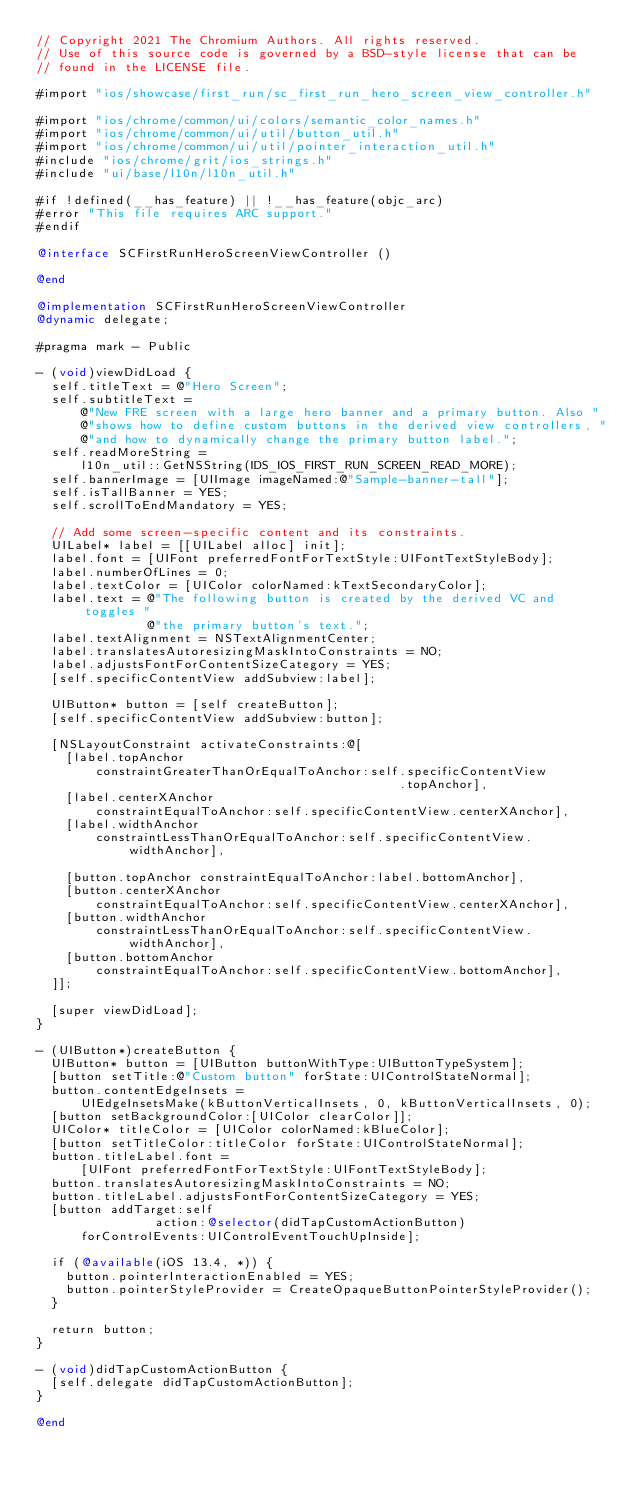Convert code to text. <code><loc_0><loc_0><loc_500><loc_500><_ObjectiveC_>// Copyright 2021 The Chromium Authors. All rights reserved.
// Use of this source code is governed by a BSD-style license that can be
// found in the LICENSE file.

#import "ios/showcase/first_run/sc_first_run_hero_screen_view_controller.h"

#import "ios/chrome/common/ui/colors/semantic_color_names.h"
#import "ios/chrome/common/ui/util/button_util.h"
#import "ios/chrome/common/ui/util/pointer_interaction_util.h"
#include "ios/chrome/grit/ios_strings.h"
#include "ui/base/l10n/l10n_util.h"

#if !defined(__has_feature) || !__has_feature(objc_arc)
#error "This file requires ARC support."
#endif

@interface SCFirstRunHeroScreenViewController ()

@end

@implementation SCFirstRunHeroScreenViewController
@dynamic delegate;

#pragma mark - Public

- (void)viewDidLoad {
  self.titleText = @"Hero Screen";
  self.subtitleText =
      @"New FRE screen with a large hero banner and a primary button. Also "
      @"shows how to define custom buttons in the derived view controllers, "
      @"and how to dynamically change the primary button label.";
  self.readMoreString =
      l10n_util::GetNSString(IDS_IOS_FIRST_RUN_SCREEN_READ_MORE);
  self.bannerImage = [UIImage imageNamed:@"Sample-banner-tall"];
  self.isTallBanner = YES;
  self.scrollToEndMandatory = YES;

  // Add some screen-specific content and its constraints.
  UILabel* label = [[UILabel alloc] init];
  label.font = [UIFont preferredFontForTextStyle:UIFontTextStyleBody];
  label.numberOfLines = 0;
  label.textColor = [UIColor colorNamed:kTextSecondaryColor];
  label.text = @"The following button is created by the derived VC and toggles "
               @"the primary button's text.";
  label.textAlignment = NSTextAlignmentCenter;
  label.translatesAutoresizingMaskIntoConstraints = NO;
  label.adjustsFontForContentSizeCategory = YES;
  [self.specificContentView addSubview:label];

  UIButton* button = [self createButton];
  [self.specificContentView addSubview:button];

  [NSLayoutConstraint activateConstraints:@[
    [label.topAnchor
        constraintGreaterThanOrEqualToAnchor:self.specificContentView
                                                 .topAnchor],
    [label.centerXAnchor
        constraintEqualToAnchor:self.specificContentView.centerXAnchor],
    [label.widthAnchor
        constraintLessThanOrEqualToAnchor:self.specificContentView.widthAnchor],

    [button.topAnchor constraintEqualToAnchor:label.bottomAnchor],
    [button.centerXAnchor
        constraintEqualToAnchor:self.specificContentView.centerXAnchor],
    [button.widthAnchor
        constraintLessThanOrEqualToAnchor:self.specificContentView.widthAnchor],
    [button.bottomAnchor
        constraintEqualToAnchor:self.specificContentView.bottomAnchor],
  ]];

  [super viewDidLoad];
}

- (UIButton*)createButton {
  UIButton* button = [UIButton buttonWithType:UIButtonTypeSystem];
  [button setTitle:@"Custom button" forState:UIControlStateNormal];
  button.contentEdgeInsets =
      UIEdgeInsetsMake(kButtonVerticalInsets, 0, kButtonVerticalInsets, 0);
  [button setBackgroundColor:[UIColor clearColor]];
  UIColor* titleColor = [UIColor colorNamed:kBlueColor];
  [button setTitleColor:titleColor forState:UIControlStateNormal];
  button.titleLabel.font =
      [UIFont preferredFontForTextStyle:UIFontTextStyleBody];
  button.translatesAutoresizingMaskIntoConstraints = NO;
  button.titleLabel.adjustsFontForContentSizeCategory = YES;
  [button addTarget:self
                action:@selector(didTapCustomActionButton)
      forControlEvents:UIControlEventTouchUpInside];

  if (@available(iOS 13.4, *)) {
    button.pointerInteractionEnabled = YES;
    button.pointerStyleProvider = CreateOpaqueButtonPointerStyleProvider();
  }

  return button;
}

- (void)didTapCustomActionButton {
  [self.delegate didTapCustomActionButton];
}

@end
</code> 